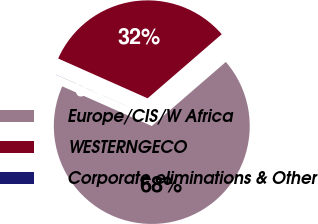Convert chart to OTSL. <chart><loc_0><loc_0><loc_500><loc_500><pie_chart><fcel>Europe/CIS/W Africa<fcel>WESTERNGECO<fcel>Corporate eliminations & Other<nl><fcel>67.99%<fcel>31.99%<fcel>0.02%<nl></chart> 